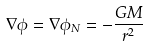<formula> <loc_0><loc_0><loc_500><loc_500>\nabla \phi = \nabla \phi _ { N } = - \frac { G M } { r ^ { 2 } }</formula> 